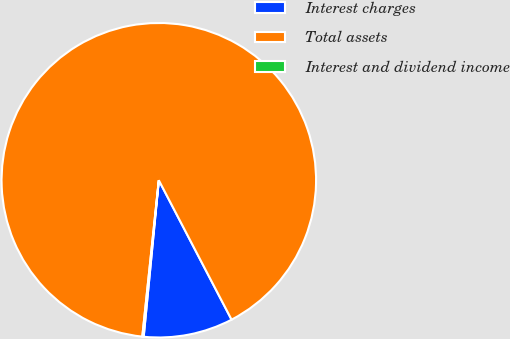<chart> <loc_0><loc_0><loc_500><loc_500><pie_chart><fcel>Interest charges<fcel>Total assets<fcel>Interest and dividend income<nl><fcel>9.19%<fcel>90.67%<fcel>0.14%<nl></chart> 